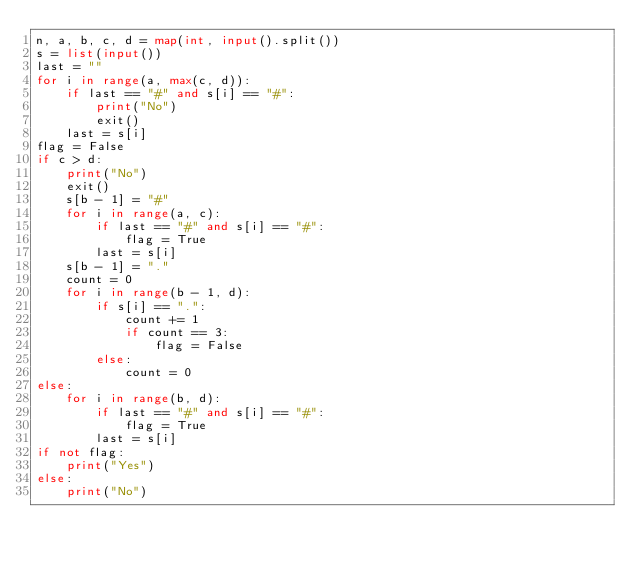<code> <loc_0><loc_0><loc_500><loc_500><_Python_>n, a, b, c, d = map(int, input().split())
s = list(input())
last = ""
for i in range(a, max(c, d)):
    if last == "#" and s[i] == "#":
        print("No")
        exit()
    last = s[i]
flag = False
if c > d:
    print("No")
    exit()
    s[b - 1] = "#"
    for i in range(a, c):
        if last == "#" and s[i] == "#":
            flag = True
        last = s[i]
    s[b - 1] = "."
    count = 0
    for i in range(b - 1, d):
        if s[i] == ".":
            count += 1
            if count == 3:
                flag = False
        else:
            count = 0
else:
    for i in range(b, d):
        if last == "#" and s[i] == "#":
            flag = True
        last = s[i]
if not flag:
    print("Yes")
else:
    print("No")</code> 